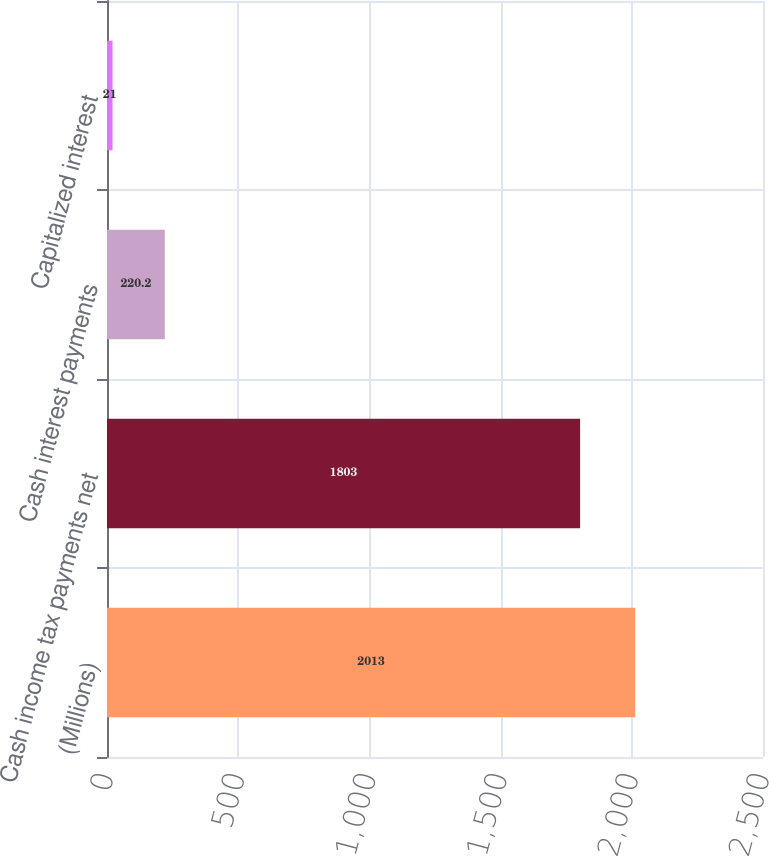Convert chart. <chart><loc_0><loc_0><loc_500><loc_500><bar_chart><fcel>(Millions)<fcel>Cash income tax payments net<fcel>Cash interest payments<fcel>Capitalized interest<nl><fcel>2013<fcel>1803<fcel>220.2<fcel>21<nl></chart> 